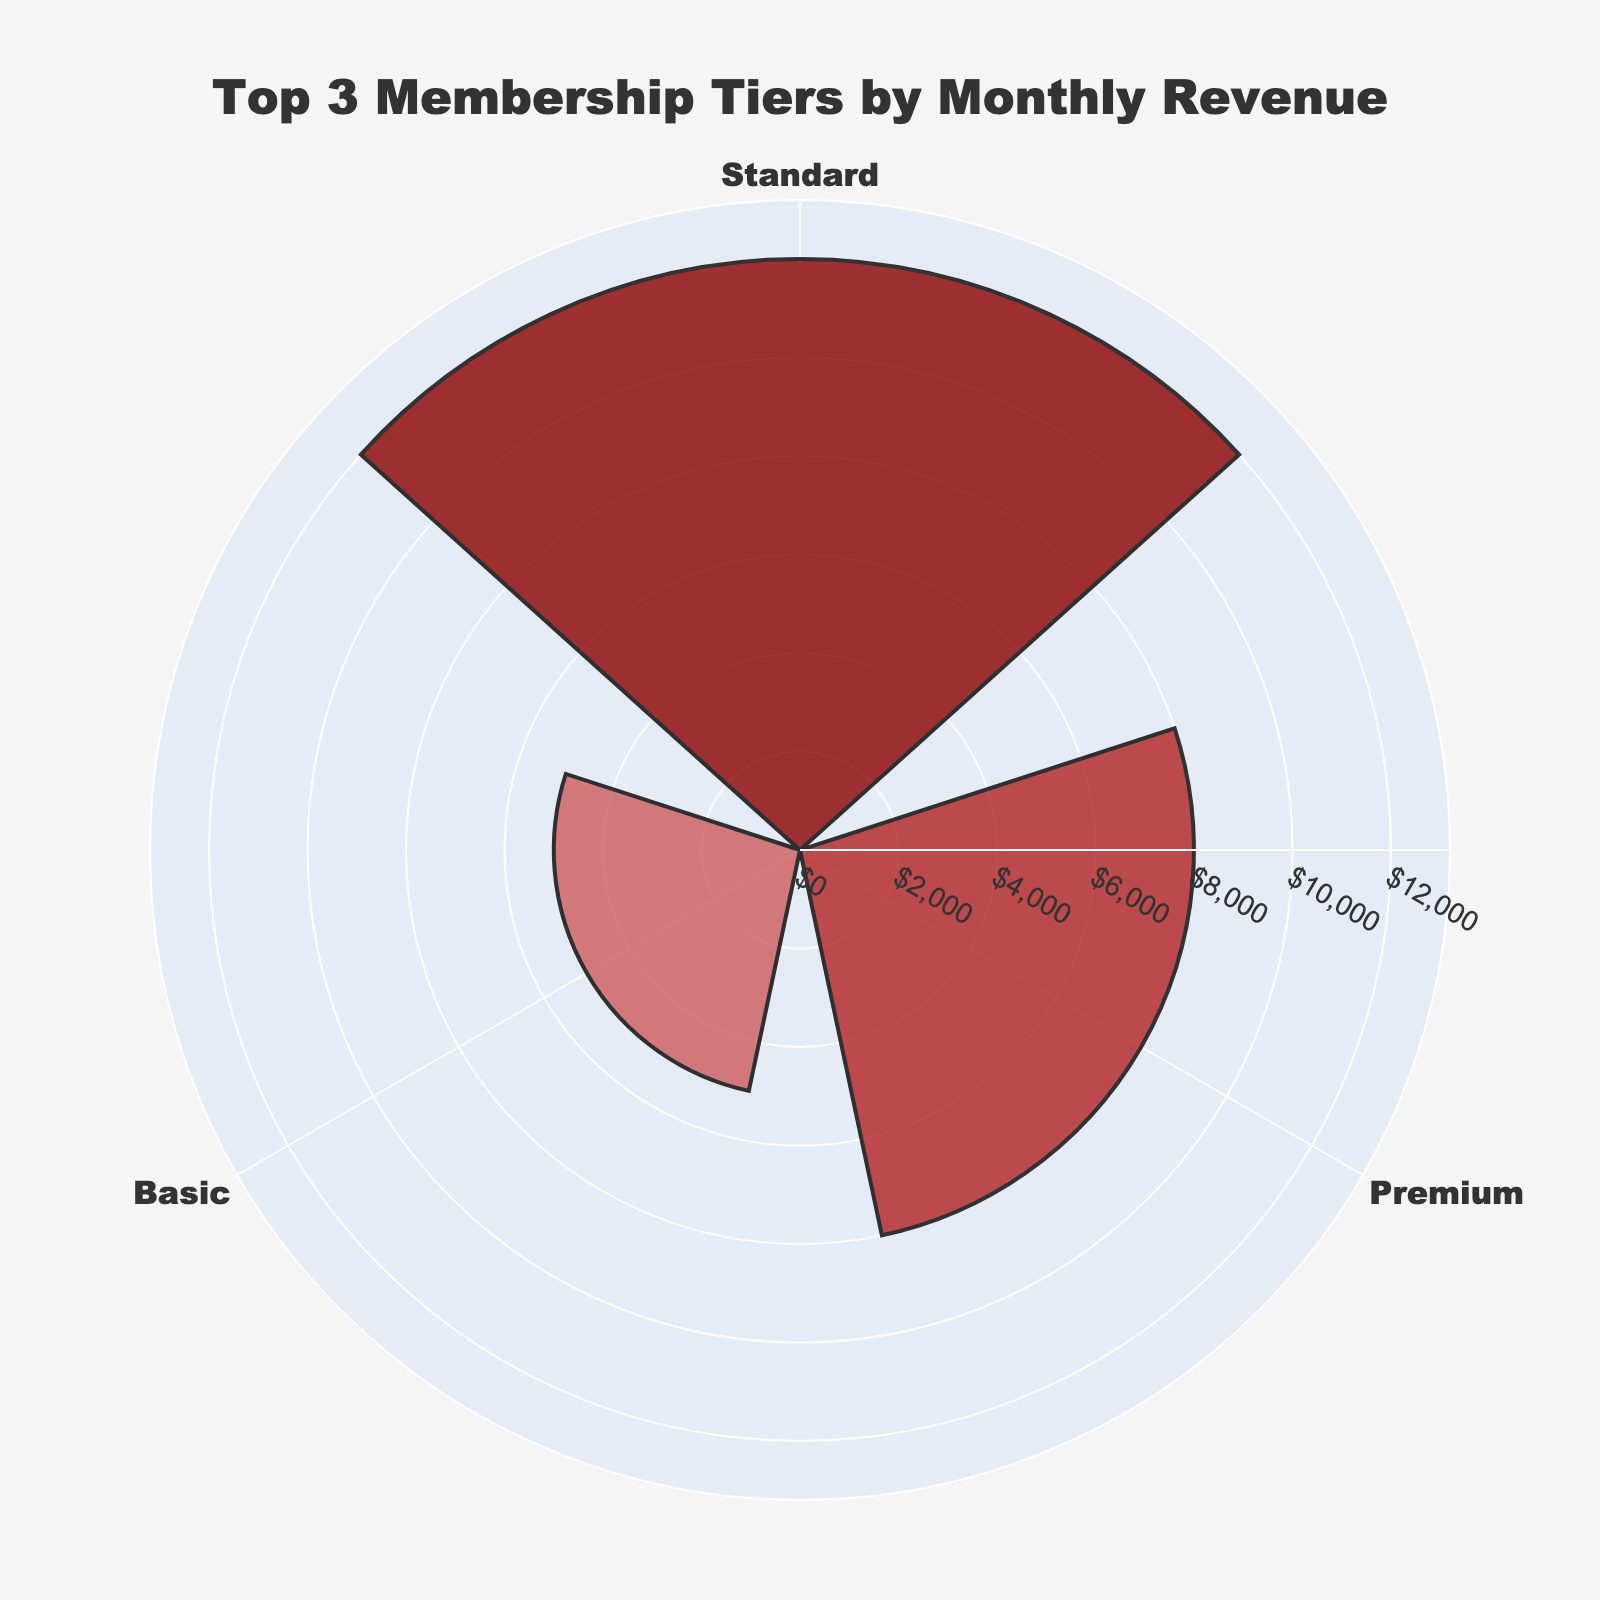what's the title of the chart? The chart has a title at the top center. By looking at that title, you can identify it.
Answer: Top 3 Membership Tiers by Monthly Revenue how many membership tiers are shown in the chart? The chart displays sectors in a circular layout, each representing a different membership tier. Count these sectors to determine the number of tiers shown.
Answer: 3 which membership tier generates the highest monthly revenue? The chart uses radial bars to represent monthly revenue, with higher values extending further from the center. The tier with the longest bar represents the highest revenue.
Answer: Standard how much more revenue does the Standard tier generate than the Premium tier? First, identify the monthly revenues for Standard and Premium tiers from the chart. Subtract the Premium revenue from the Standard revenue to find the difference.
Answer: 4000 what's the average monthly revenue of the top 3 membership tiers? Add the monthly revenues of the top 3 tiers (Standard, Premium, and Basic) and divide by 3 to find the average. (12000 + 8000 + 5000) / 3 = 8333.33
Answer: 8333.33 how are the bar colors differentiated among membership tiers? The chart uses different shades of red for each membership tier's bar. Observe that each bar has a unique shade to distinguish the tiers.
Answer: Different shades of red which membership tier is closest in revenue to the Premium tier? Compare the lengths of the bars representing each tier. The bar that is closest in length to the Premium tier without exceeding it is the Basic tier.
Answer: Basic what is the range of the radial axis? Look at the radial axis markings on the chart, which indicate the range. Note the minimum and maximum values displayed.
Answer: 0 to 13200 